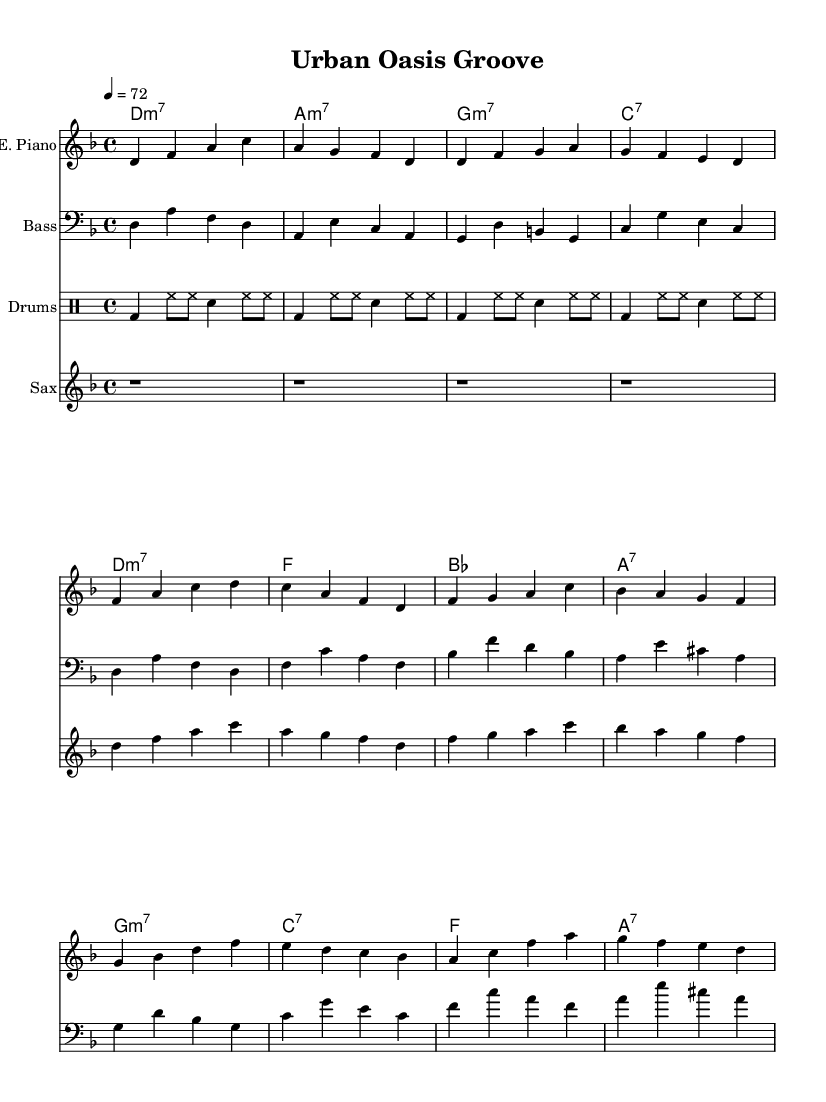What is the key signature of this music? The key signature is identified by the presence of the key signature symbol at the beginning of the staff. Here, it is identified as D minor which has one flat (B flat).
Answer: D minor What is the time signature of this piece? The time signature is indicated at the start of the score, represented as 4/4, meaning there are four beats in each measure and the quarter note gets one beat.
Answer: 4/4 What is the tempo marking for this piece? The tempo marking is provided at the beginning, indicating the speed of the piece. It reads "4 = 72," which means there should be 72 quarter note beats per minute.
Answer: 72 How many bars are there in the verse section? The verse section consists of eight measures, and this can be counted from the bar lines shown between the notes for the electric piano and other parts.
Answer: 8 What instrument plays the bass line? The bass line is performed by the instrument marked as "Bass" in the score, indicating that it is played on a bass guitar.
Answer: Bass guitar What chord is played in the bridge section? In the bridge section, the first measure shows the chord symbol "g:m7," indicating this is the chord occurring in the bridge.
Answer: g:m7 What is the primary rhythmic pattern of the drums? The drums feature a basic funk pattern which can be observed in the drummode section, characterized by a bass drum on beat 1, with hi-hats and snare on the alternating beats.
Answer: Basic funk pattern 